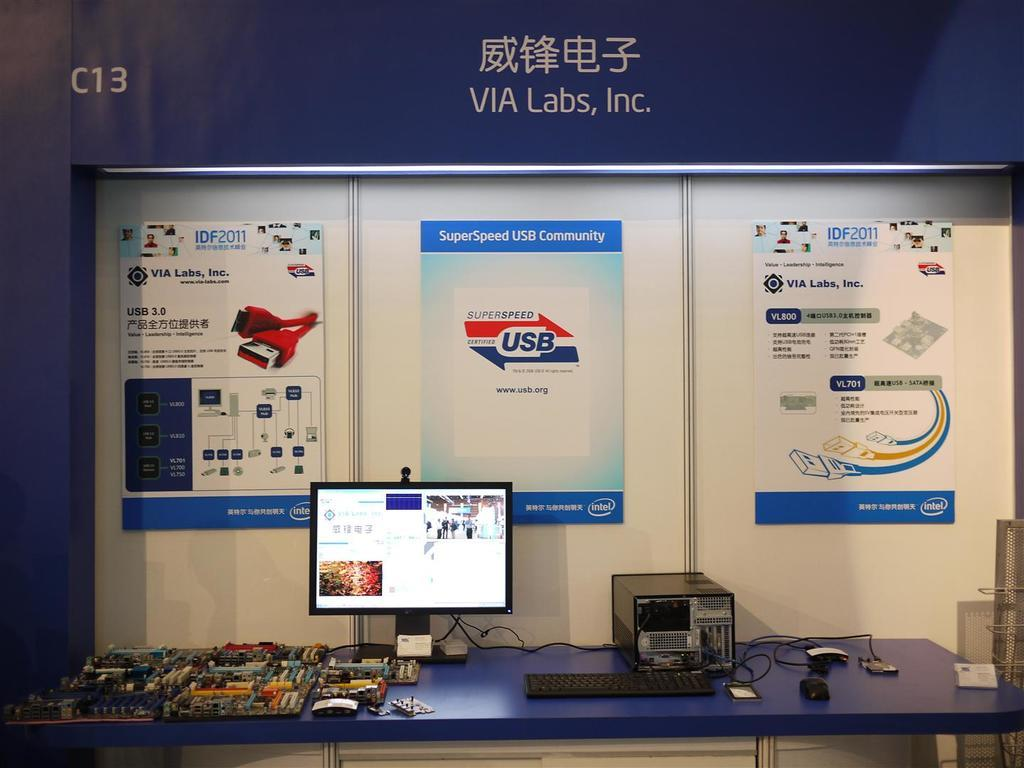<image>
Offer a succinct explanation of the picture presented. a circuit board with C13 and Via labs inc written on it 